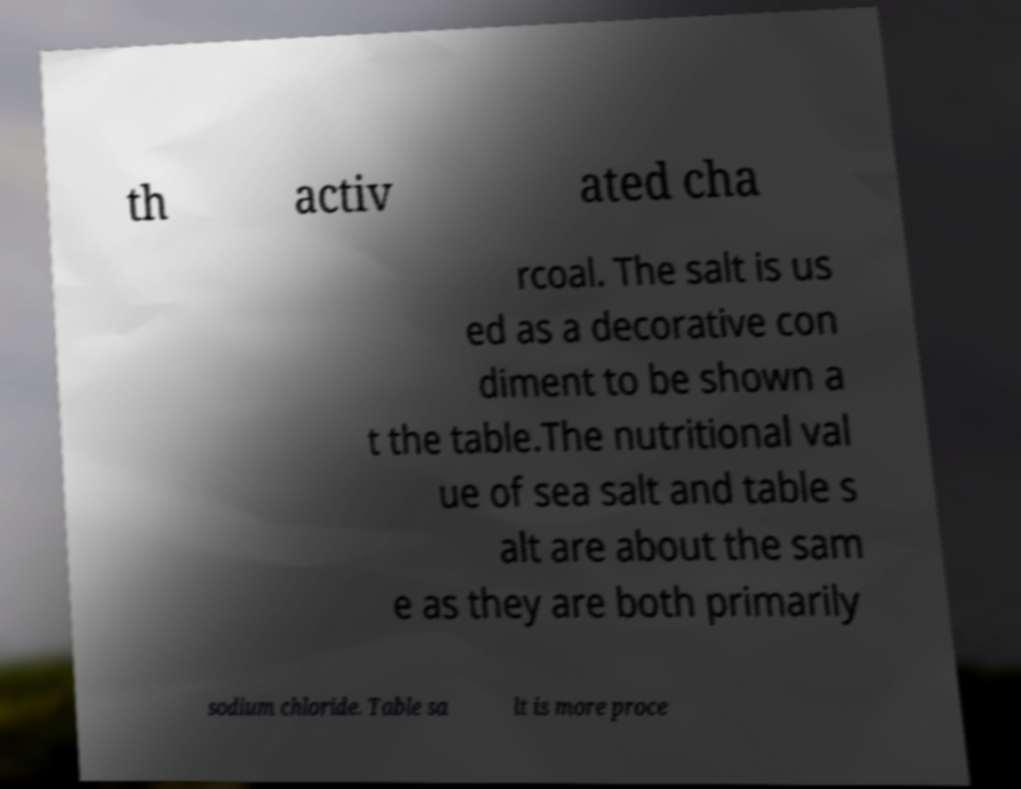Could you assist in decoding the text presented in this image and type it out clearly? th activ ated cha rcoal. The salt is us ed as a decorative con diment to be shown a t the table.The nutritional val ue of sea salt and table s alt are about the sam e as they are both primarily sodium chloride. Table sa lt is more proce 